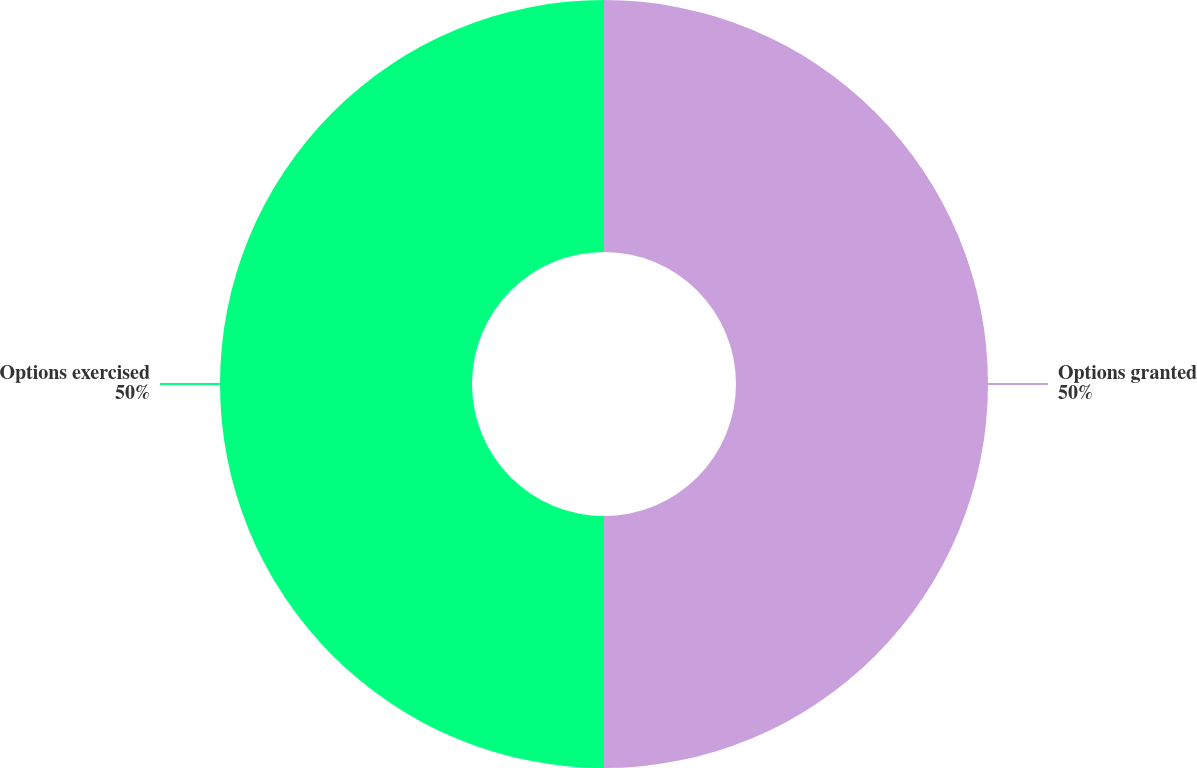Convert chart. <chart><loc_0><loc_0><loc_500><loc_500><pie_chart><fcel>Options granted<fcel>Options exercised<nl><fcel>50.0%<fcel>50.0%<nl></chart> 